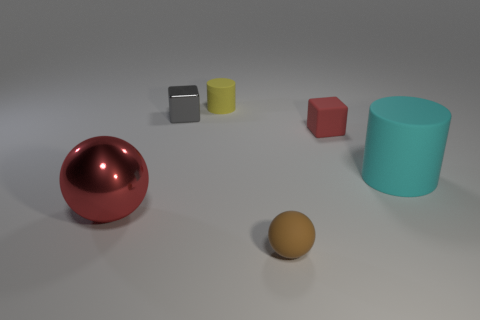Subtract all yellow cylinders. How many cylinders are left? 1 Add 1 tiny purple shiny cylinders. How many objects exist? 7 Subtract all spheres. How many objects are left? 4 Subtract 1 cylinders. How many cylinders are left? 1 Subtract all purple spheres. Subtract all yellow cylinders. How many spheres are left? 2 Subtract all red matte cubes. Subtract all big red objects. How many objects are left? 4 Add 5 small cylinders. How many small cylinders are left? 6 Add 5 tiny yellow cylinders. How many tiny yellow cylinders exist? 6 Subtract 0 cyan cubes. How many objects are left? 6 